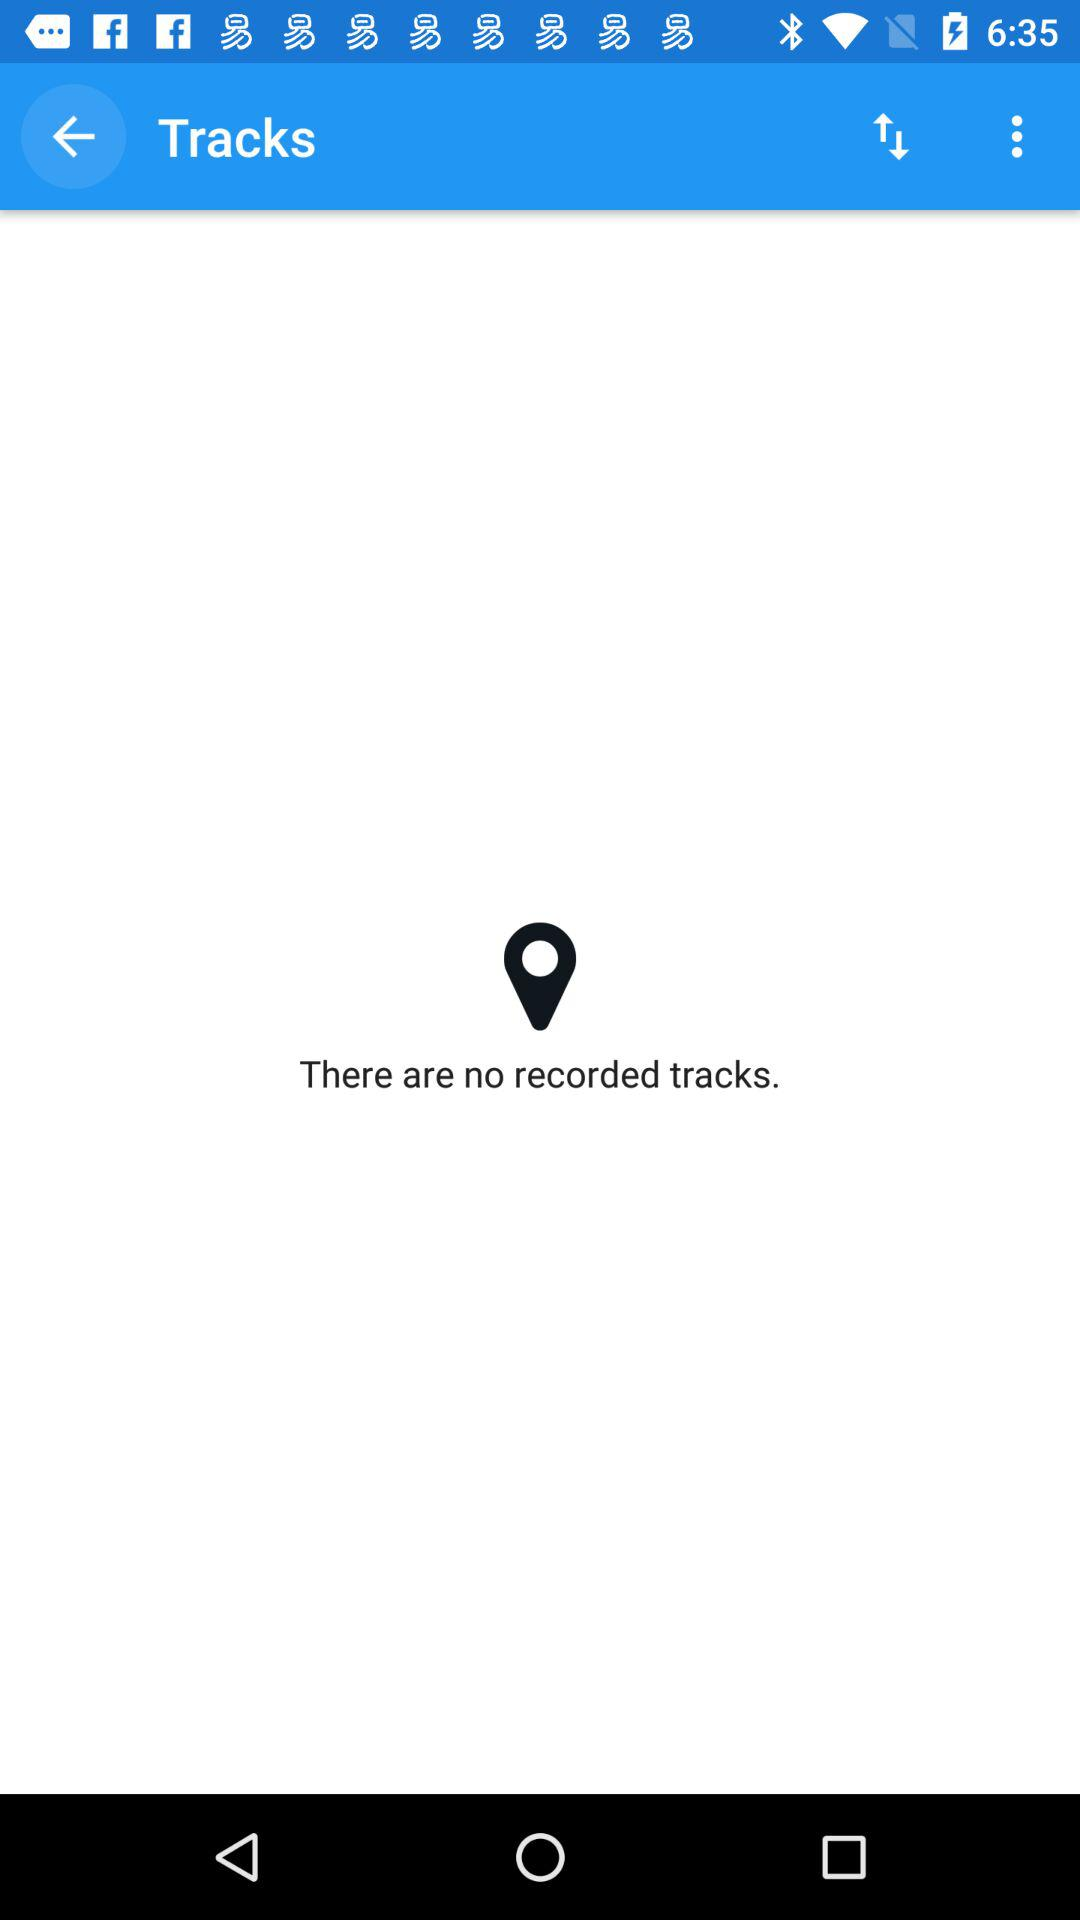How can we upload a recorded track?
When the provided information is insufficient, respond with <no answer>. <no answer> 